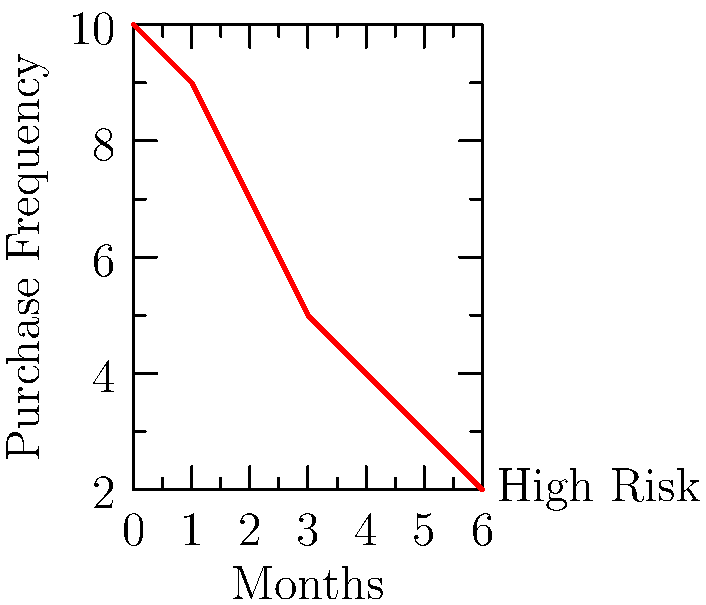Based on the graph showing purchase frequency over time, at which point should a salesperson intervene to prevent potential customer churn? To determine when a salesperson should intervene to prevent potential customer churn, we need to analyze the trend in the purchase frequency graph:

1. Observe the overall trend: The graph shows a consistent decline in purchase frequency over time.

2. Identify the rate of decline: The steepest decline occurs between months 0 and 3.

3. Recognize the critical point: After month 3, the decline rate slows down, but the purchase frequency continues to decrease.

4. Consider intervention timing: Ideally, intervention should occur before the customer reaches the critical point of rapid decline.

5. Optimal intervention point: Month 2 represents the last data point before the steepest decline ends, making it the best time for a salesperson to intervene.

6. Justification: Intervening at month 2 allows the salesperson to address potential issues before the customer's purchase frequency drops significantly, increasing the chances of preventing churn.
Answer: Month 2 